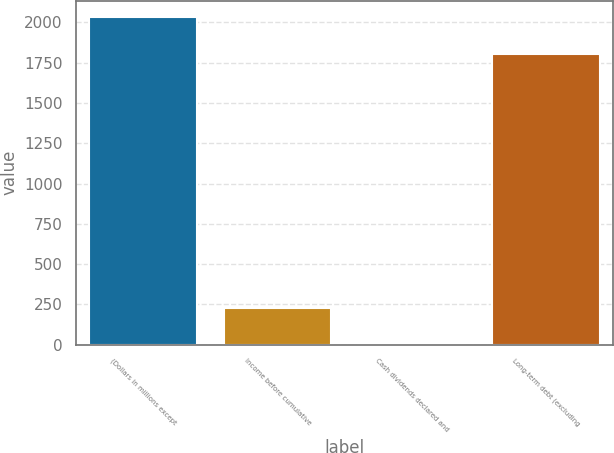Convert chart to OTSL. <chart><loc_0><loc_0><loc_500><loc_500><bar_chart><fcel>(Dollars in millions except<fcel>Income before cumulative<fcel>Cash dividends declared and<fcel>Long-term debt (excluding<nl><fcel>2033.47<fcel>229.79<fcel>1.32<fcel>1805<nl></chart> 